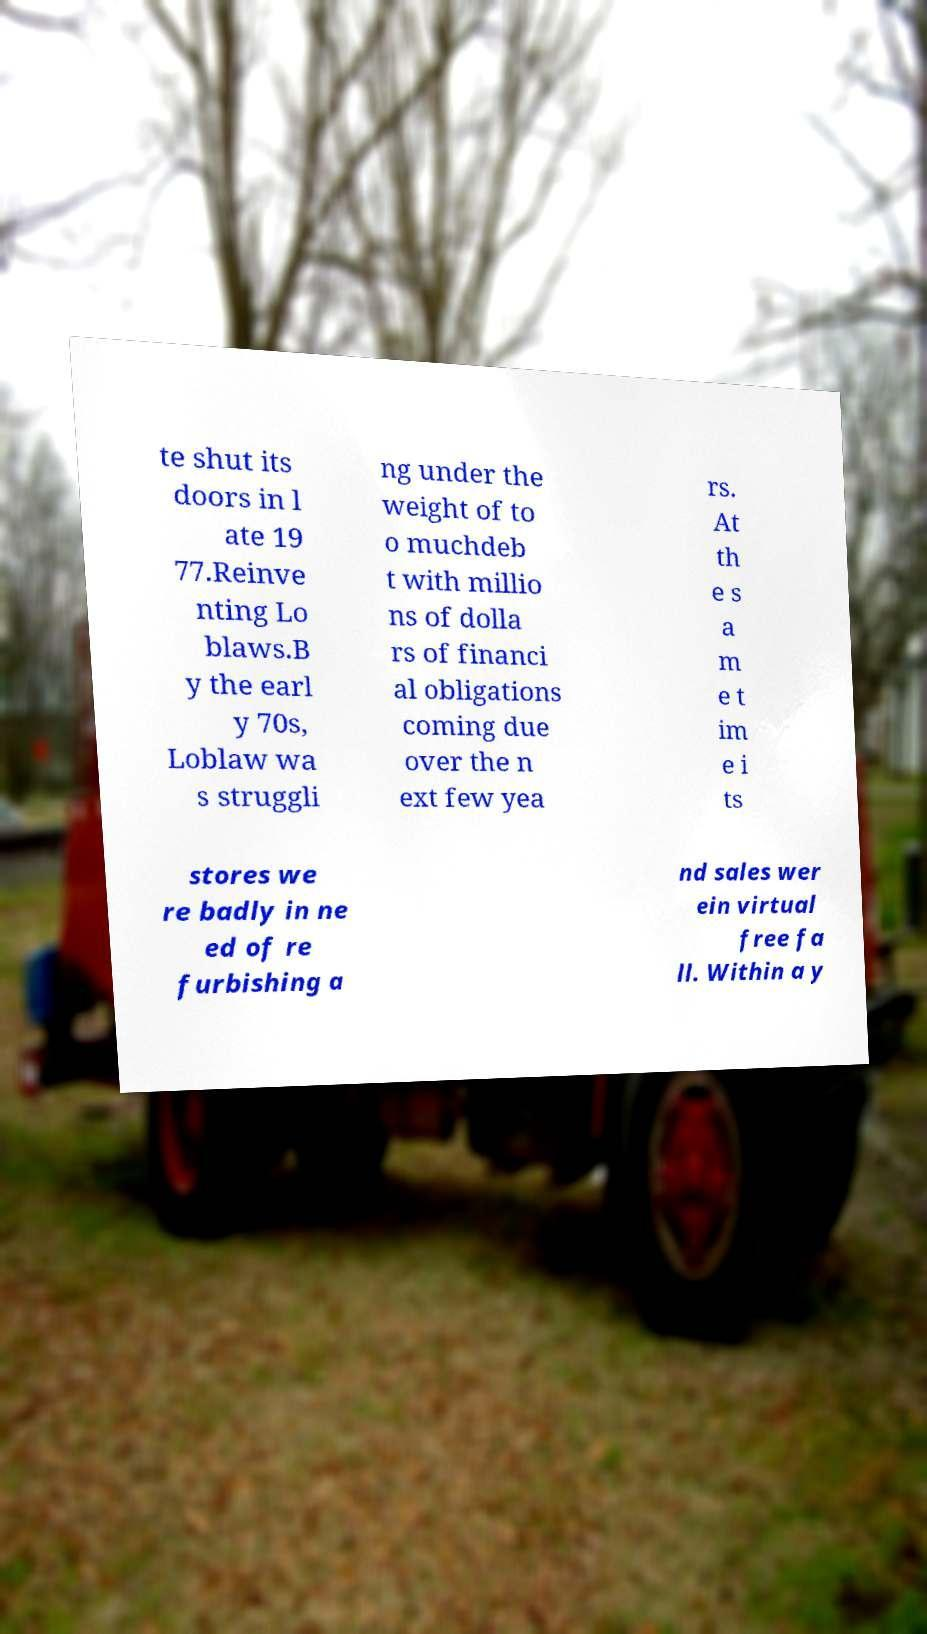What messages or text are displayed in this image? I need them in a readable, typed format. te shut its doors in l ate 19 77.Reinve nting Lo blaws.B y the earl y 70s, Loblaw wa s struggli ng under the weight of to o muchdeb t with millio ns of dolla rs of financi al obligations coming due over the n ext few yea rs. At th e s a m e t im e i ts stores we re badly in ne ed of re furbishing a nd sales wer ein virtual free fa ll. Within a y 